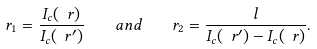<formula> <loc_0><loc_0><loc_500><loc_500>r _ { 1 } = \frac { I _ { c } ( \ r ) } { I _ { c } ( \ r ^ { \prime } ) } \quad a n d \quad r _ { 2 } = \frac { l } { I _ { c } ( \ r ^ { \prime } ) - I _ { c } ( \ r ) } .</formula> 